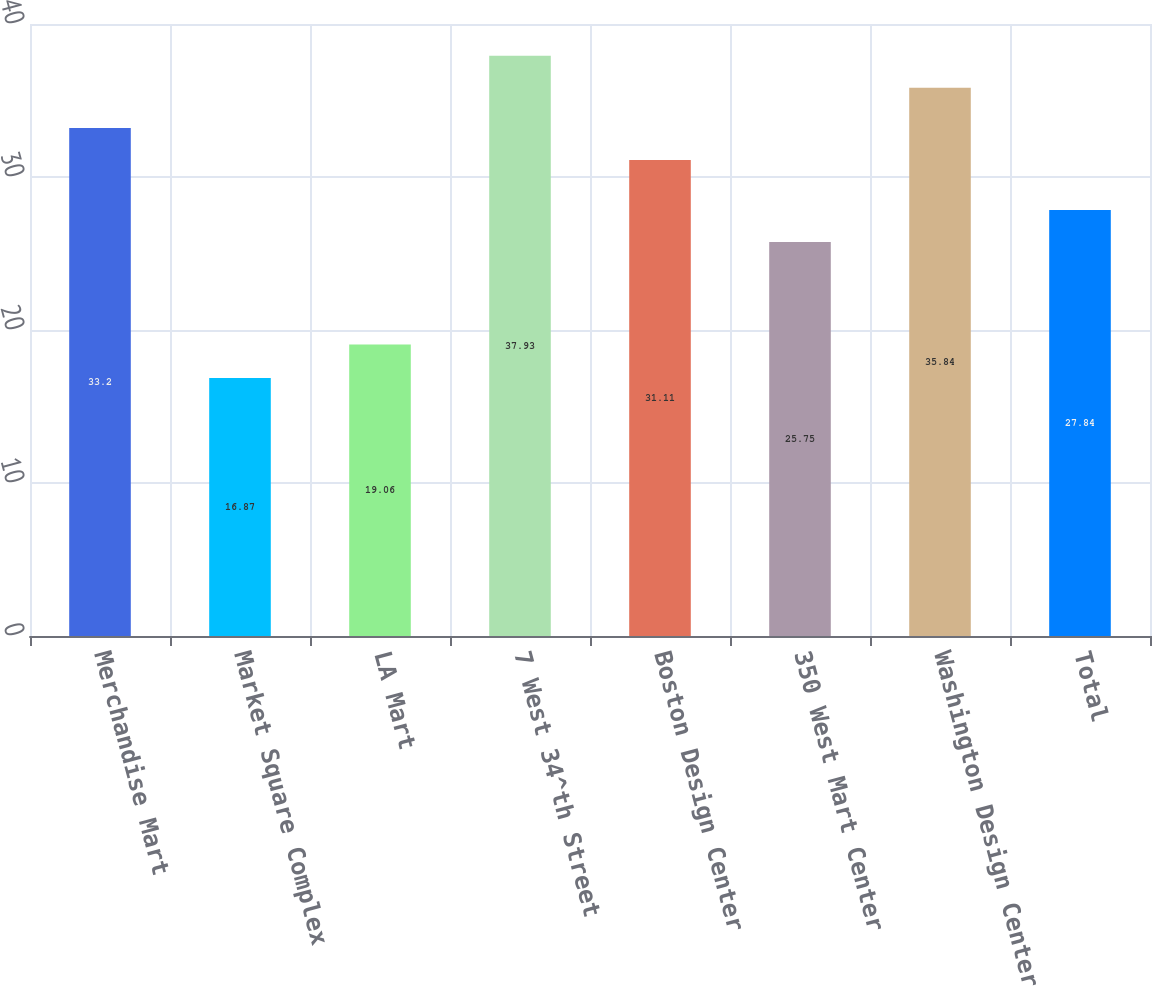Convert chart to OTSL. <chart><loc_0><loc_0><loc_500><loc_500><bar_chart><fcel>Merchandise Mart<fcel>Market Square Complex<fcel>LA Mart<fcel>7 West 34^th Street<fcel>Boston Design Center<fcel>350 West Mart Center<fcel>Washington Design Center<fcel>Total<nl><fcel>33.2<fcel>16.87<fcel>19.06<fcel>37.93<fcel>31.11<fcel>25.75<fcel>35.84<fcel>27.84<nl></chart> 